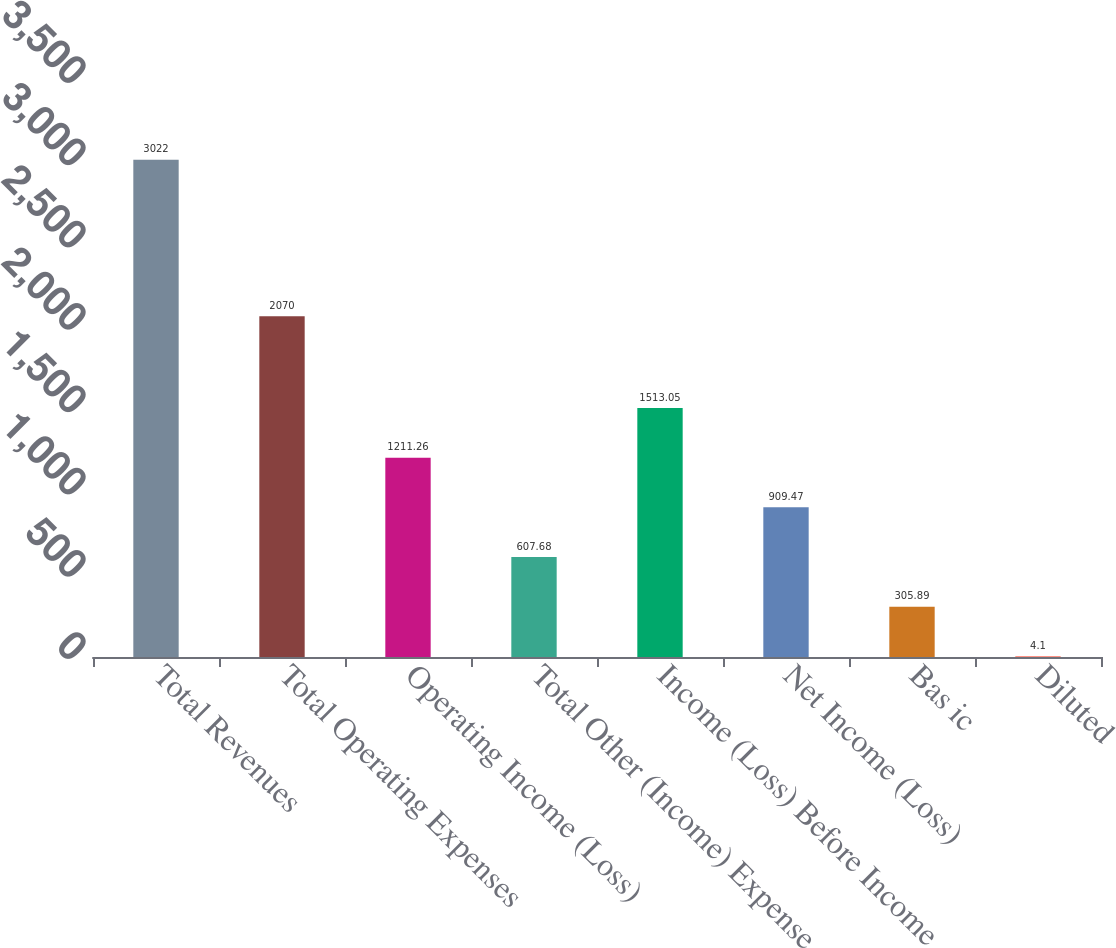<chart> <loc_0><loc_0><loc_500><loc_500><bar_chart><fcel>Total Revenues<fcel>Total Operating Expenses<fcel>Operating Income (Loss)<fcel>Total Other (Income) Expense<fcel>Income (Loss) Before Income<fcel>Net Income (Loss)<fcel>Bas ic<fcel>Diluted<nl><fcel>3022<fcel>2070<fcel>1211.26<fcel>607.68<fcel>1513.05<fcel>909.47<fcel>305.89<fcel>4.1<nl></chart> 